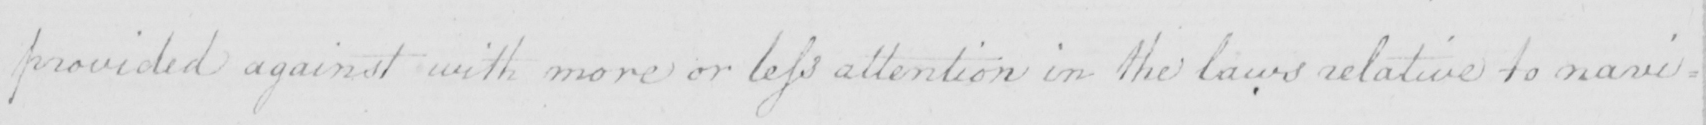Please transcribe the handwritten text in this image. provided against with more or less attention in the laws relative to navi= 